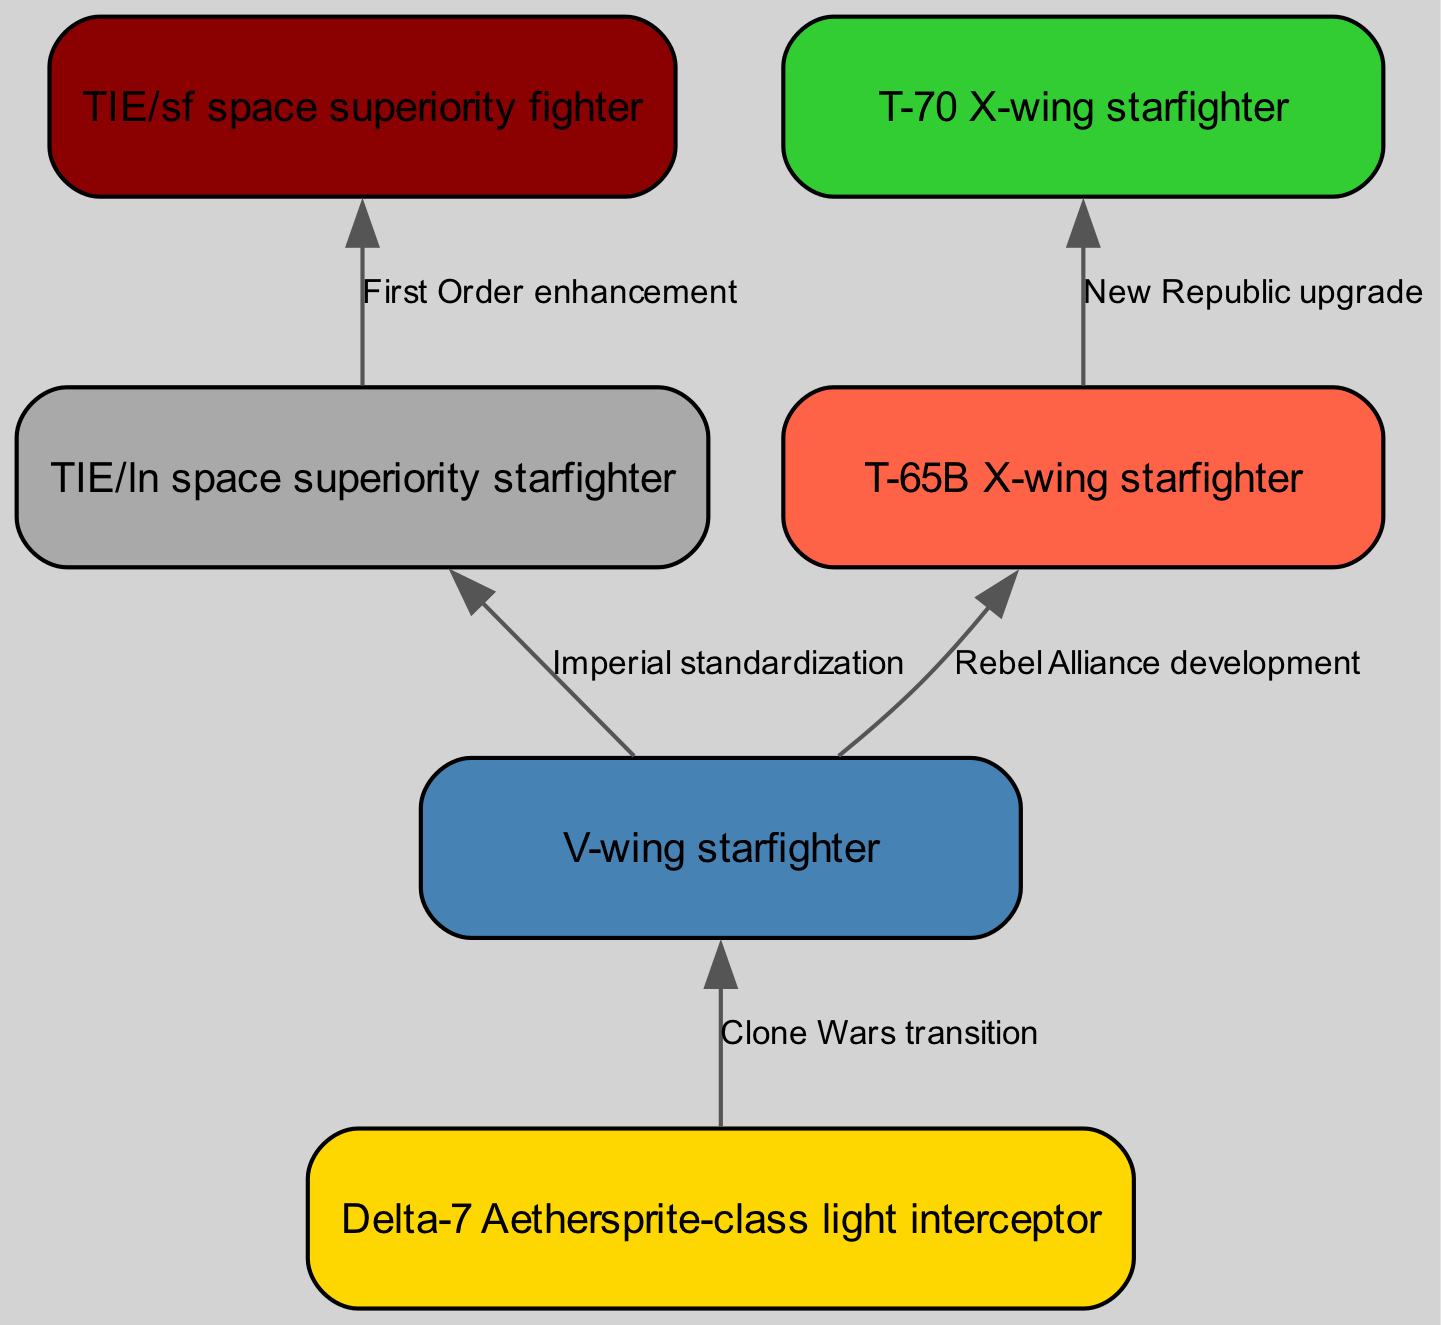What is the earliest starfighter in the diagram? The diagram starts with the Delta-7 Aethersprite-class light interceptor as the first node, indicating it is the earliest starfighter listed in the timeline.
Answer: Delta-7 Aethersprite-class light interceptor How many nodes are present in the diagram? The diagram lists a total of six distinct nodes representing different starfighters, hence there are six nodes in total.
Answer: 6 What is the relationship between the V-wing starfighter and the TIE/ln space superiority starfighter? The diagram shows that the V-wing starfighter leads to both the TIE/ln space superiority starfighter and the T-65B X-wing starfighter, indicating that the V-wing served as a transitional or developmental phase towards these fighters.
Answer: Imperial standardization and Rebel Alliance development Which starfighter received upgrades during the New Republic era? The T-70 X-wing starfighter is connected to the T-65B X-wing starfighter with the label "New Republic upgrade," indicating that it was upgraded during this era.
Answer: T-70 X-wing starfighter What color represents the Old Republic starfighter in the diagram? The Delta-7 Aethersprite-class light interceptor, which is associated with the Old Republic, is colored gold (#FFD700) in the diagram, indicating that it visually represents this era.
Answer: Gold How many transitions are depicted in the diagram? The diagram depicts five distinct transitions from one starfighter to another, represented by edges connecting the nodes.
Answer: 5 Which starfighter follows the TIE/ln space superiority starfighter? According to the diagram, the TIE/sf space superiority fighter follows the TIE/ln space superiority starfighter, as it is the direct connection in the flow.
Answer: TIE/sf space superiority fighter What era does the TIE/sf space superiority fighter belong to? The TIE/sf space superiority fighter is linked to the First Order enhancement, suggesting it belongs to the First Order era.
Answer: First Order Which two starfighters are developed during the Clone Wars? The V-wing starfighter is named, and it is established as a development during the Clone Wars, transitioning from the Delta-7 Aethersprite-class light interceptor.
Answer: V-wing starfighter and Delta-7 Aethersprite-class light interceptor 